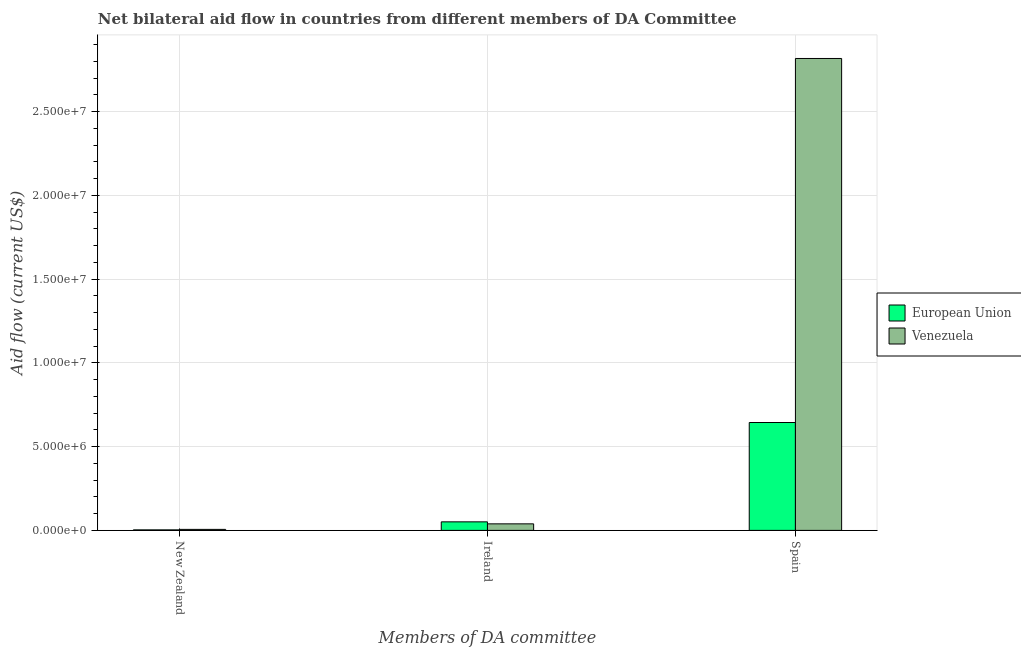How many groups of bars are there?
Your response must be concise. 3. Are the number of bars on each tick of the X-axis equal?
Give a very brief answer. Yes. How many bars are there on the 2nd tick from the left?
Provide a succinct answer. 2. How many bars are there on the 2nd tick from the right?
Your answer should be compact. 2. What is the label of the 3rd group of bars from the left?
Your answer should be very brief. Spain. What is the amount of aid provided by new zealand in European Union?
Your answer should be very brief. 3.00e+04. Across all countries, what is the maximum amount of aid provided by new zealand?
Provide a short and direct response. 6.00e+04. Across all countries, what is the minimum amount of aid provided by ireland?
Offer a very short reply. 3.90e+05. In which country was the amount of aid provided by spain maximum?
Provide a succinct answer. Venezuela. In which country was the amount of aid provided by ireland minimum?
Ensure brevity in your answer.  Venezuela. What is the total amount of aid provided by new zealand in the graph?
Provide a short and direct response. 9.00e+04. What is the difference between the amount of aid provided by spain in Venezuela and that in European Union?
Offer a very short reply. 2.17e+07. What is the difference between the amount of aid provided by spain in Venezuela and the amount of aid provided by ireland in European Union?
Keep it short and to the point. 2.77e+07. What is the average amount of aid provided by new zealand per country?
Ensure brevity in your answer.  4.50e+04. What is the difference between the amount of aid provided by new zealand and amount of aid provided by ireland in European Union?
Your answer should be very brief. -4.80e+05. What is the ratio of the amount of aid provided by ireland in European Union to that in Venezuela?
Give a very brief answer. 1.31. Is the amount of aid provided by ireland in European Union less than that in Venezuela?
Your answer should be compact. No. Is the difference between the amount of aid provided by new zealand in Venezuela and European Union greater than the difference between the amount of aid provided by ireland in Venezuela and European Union?
Offer a very short reply. Yes. What is the difference between the highest and the lowest amount of aid provided by new zealand?
Offer a very short reply. 3.00e+04. In how many countries, is the amount of aid provided by spain greater than the average amount of aid provided by spain taken over all countries?
Ensure brevity in your answer.  1. Is the sum of the amount of aid provided by ireland in European Union and Venezuela greater than the maximum amount of aid provided by spain across all countries?
Your response must be concise. No. What does the 1st bar from the left in New Zealand represents?
Your answer should be compact. European Union. What does the 1st bar from the right in Spain represents?
Ensure brevity in your answer.  Venezuela. How many bars are there?
Give a very brief answer. 6. What is the difference between two consecutive major ticks on the Y-axis?
Ensure brevity in your answer.  5.00e+06. Does the graph contain any zero values?
Make the answer very short. No. What is the title of the graph?
Your answer should be compact. Net bilateral aid flow in countries from different members of DA Committee. What is the label or title of the X-axis?
Your response must be concise. Members of DA committee. What is the label or title of the Y-axis?
Make the answer very short. Aid flow (current US$). What is the Aid flow (current US$) in European Union in New Zealand?
Provide a short and direct response. 3.00e+04. What is the Aid flow (current US$) in European Union in Ireland?
Offer a terse response. 5.10e+05. What is the Aid flow (current US$) of European Union in Spain?
Your answer should be very brief. 6.44e+06. What is the Aid flow (current US$) in Venezuela in Spain?
Your answer should be very brief. 2.82e+07. Across all Members of DA committee, what is the maximum Aid flow (current US$) of European Union?
Your answer should be very brief. 6.44e+06. Across all Members of DA committee, what is the maximum Aid flow (current US$) of Venezuela?
Give a very brief answer. 2.82e+07. What is the total Aid flow (current US$) in European Union in the graph?
Offer a terse response. 6.98e+06. What is the total Aid flow (current US$) of Venezuela in the graph?
Offer a very short reply. 2.86e+07. What is the difference between the Aid flow (current US$) in European Union in New Zealand and that in Ireland?
Make the answer very short. -4.80e+05. What is the difference between the Aid flow (current US$) of Venezuela in New Zealand and that in Ireland?
Offer a terse response. -3.30e+05. What is the difference between the Aid flow (current US$) in European Union in New Zealand and that in Spain?
Provide a short and direct response. -6.41e+06. What is the difference between the Aid flow (current US$) of Venezuela in New Zealand and that in Spain?
Your answer should be compact. -2.81e+07. What is the difference between the Aid flow (current US$) in European Union in Ireland and that in Spain?
Offer a very short reply. -5.93e+06. What is the difference between the Aid flow (current US$) of Venezuela in Ireland and that in Spain?
Your answer should be compact. -2.78e+07. What is the difference between the Aid flow (current US$) of European Union in New Zealand and the Aid flow (current US$) of Venezuela in Ireland?
Ensure brevity in your answer.  -3.60e+05. What is the difference between the Aid flow (current US$) in European Union in New Zealand and the Aid flow (current US$) in Venezuela in Spain?
Provide a succinct answer. -2.81e+07. What is the difference between the Aid flow (current US$) of European Union in Ireland and the Aid flow (current US$) of Venezuela in Spain?
Make the answer very short. -2.77e+07. What is the average Aid flow (current US$) in European Union per Members of DA committee?
Give a very brief answer. 2.33e+06. What is the average Aid flow (current US$) of Venezuela per Members of DA committee?
Ensure brevity in your answer.  9.54e+06. What is the difference between the Aid flow (current US$) in European Union and Aid flow (current US$) in Venezuela in New Zealand?
Ensure brevity in your answer.  -3.00e+04. What is the difference between the Aid flow (current US$) in European Union and Aid flow (current US$) in Venezuela in Ireland?
Give a very brief answer. 1.20e+05. What is the difference between the Aid flow (current US$) in European Union and Aid flow (current US$) in Venezuela in Spain?
Give a very brief answer. -2.17e+07. What is the ratio of the Aid flow (current US$) of European Union in New Zealand to that in Ireland?
Offer a very short reply. 0.06. What is the ratio of the Aid flow (current US$) in Venezuela in New Zealand to that in Ireland?
Provide a succinct answer. 0.15. What is the ratio of the Aid flow (current US$) of European Union in New Zealand to that in Spain?
Provide a short and direct response. 0. What is the ratio of the Aid flow (current US$) of Venezuela in New Zealand to that in Spain?
Make the answer very short. 0. What is the ratio of the Aid flow (current US$) of European Union in Ireland to that in Spain?
Ensure brevity in your answer.  0.08. What is the ratio of the Aid flow (current US$) in Venezuela in Ireland to that in Spain?
Your answer should be very brief. 0.01. What is the difference between the highest and the second highest Aid flow (current US$) of European Union?
Give a very brief answer. 5.93e+06. What is the difference between the highest and the second highest Aid flow (current US$) in Venezuela?
Give a very brief answer. 2.78e+07. What is the difference between the highest and the lowest Aid flow (current US$) in European Union?
Provide a succinct answer. 6.41e+06. What is the difference between the highest and the lowest Aid flow (current US$) of Venezuela?
Provide a succinct answer. 2.81e+07. 